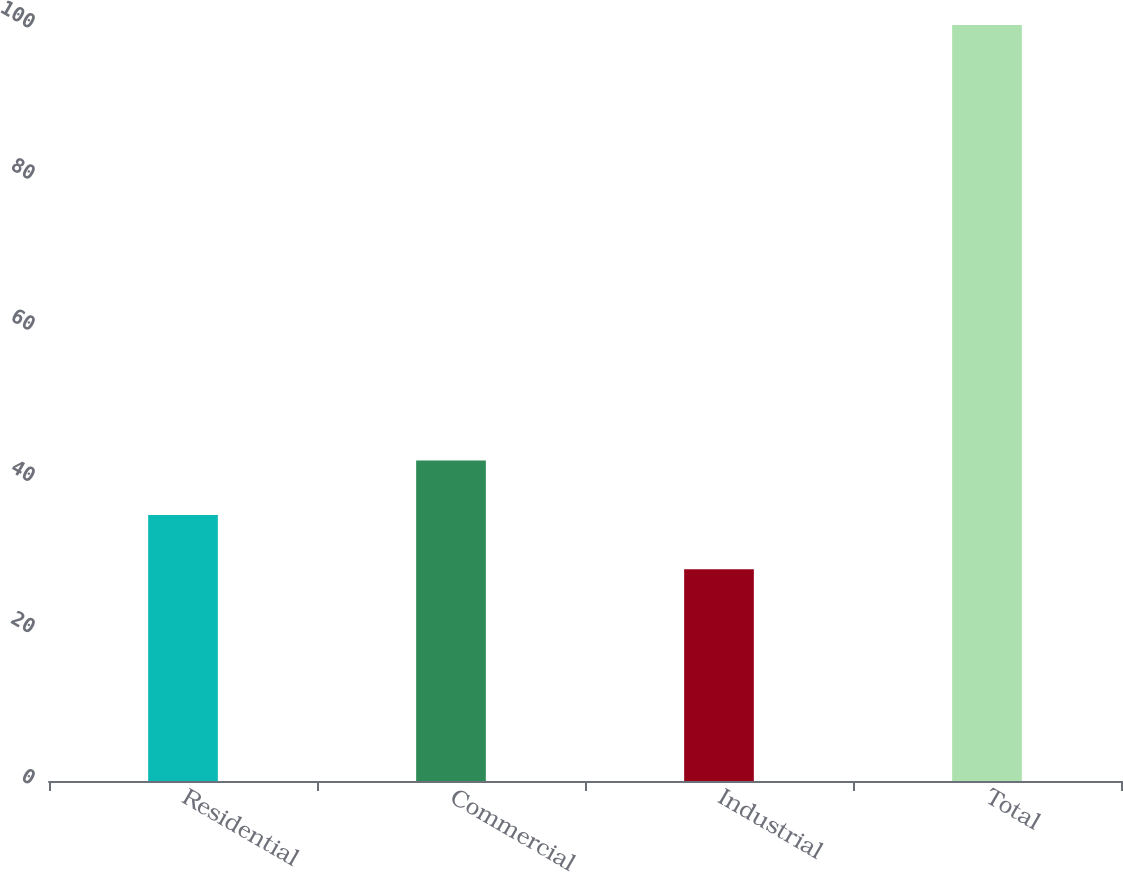<chart> <loc_0><loc_0><loc_500><loc_500><bar_chart><fcel>Residential<fcel>Commercial<fcel>Industrial<fcel>Total<nl><fcel>35.2<fcel>42.4<fcel>28<fcel>100<nl></chart> 